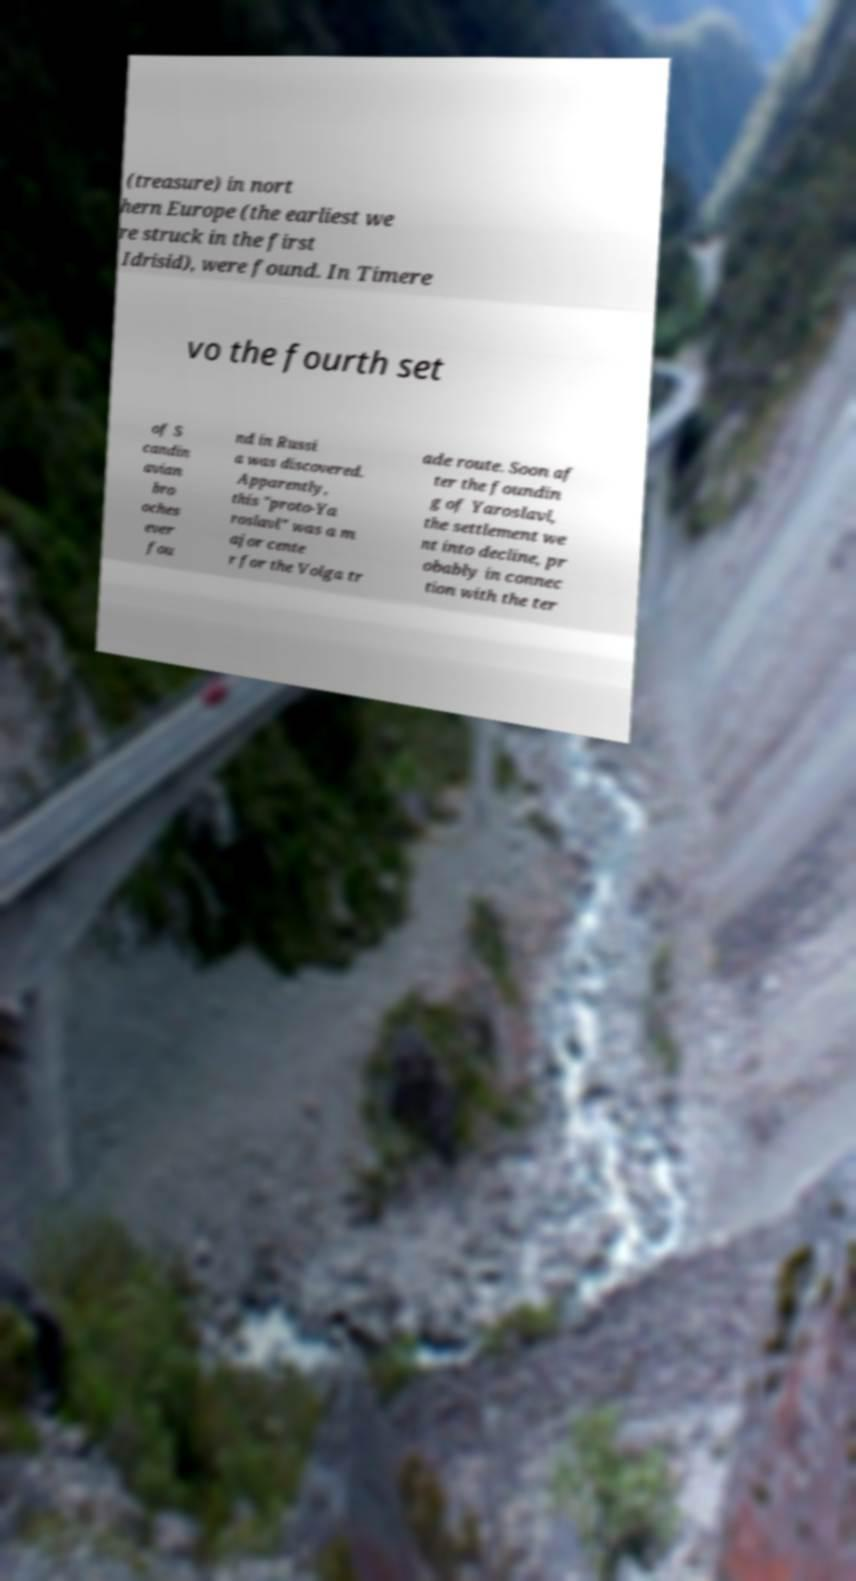What messages or text are displayed in this image? I need them in a readable, typed format. (treasure) in nort hern Europe (the earliest we re struck in the first Idrisid), were found. In Timere vo the fourth set of S candin avian bro oches ever fou nd in Russi a was discovered. Apparently, this "proto-Ya roslavl" was a m ajor cente r for the Volga tr ade route. Soon af ter the foundin g of Yaroslavl, the settlement we nt into decline, pr obably in connec tion with the ter 